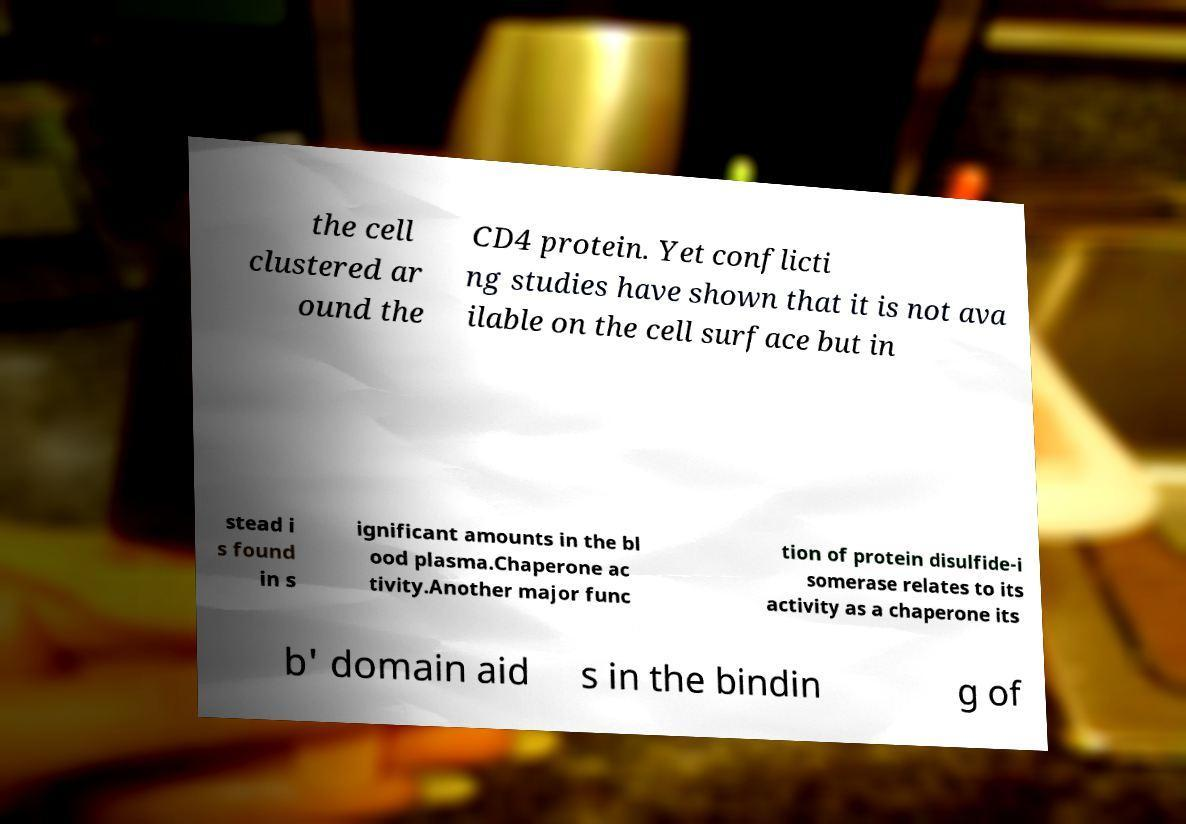Can you read and provide the text displayed in the image?This photo seems to have some interesting text. Can you extract and type it out for me? the cell clustered ar ound the CD4 protein. Yet conflicti ng studies have shown that it is not ava ilable on the cell surface but in stead i s found in s ignificant amounts in the bl ood plasma.Chaperone ac tivity.Another major func tion of protein disulfide-i somerase relates to its activity as a chaperone its b' domain aid s in the bindin g of 